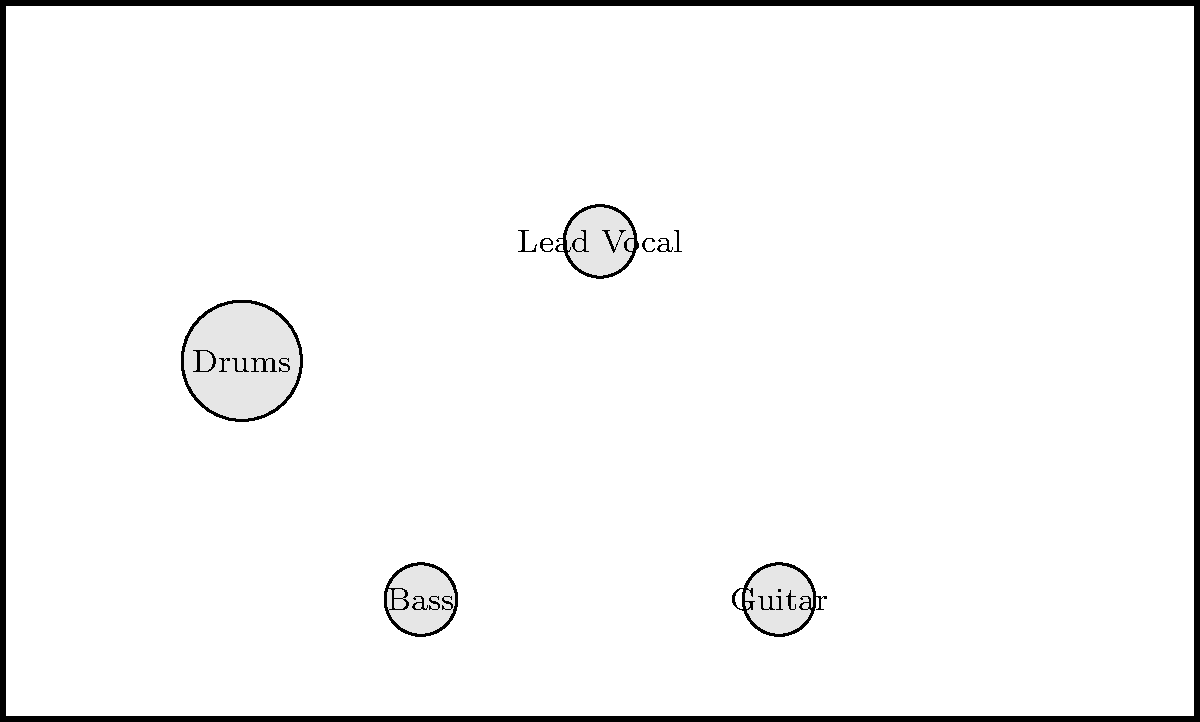As you prepare for your next live performance, you're given this stage plot diagram. Which instrument or position is placed furthest downstage (closest to the audience) according to the diagram? To answer this question, we need to analyze the stage plot diagram and understand the concept of stage positioning:

1. In stage terminology, "downstage" refers to the area of the stage closest to the audience, while "upstage" is furthest from the audience.

2. In this diagram, the bottom of the image represents the front of the stage (downstage), and the top represents the back of the stage (upstage).

3. Let's examine the positions of each instrument/performer:
   - Drums: Located near the center, slightly towards the back
   - Lead Vocal: Positioned in the center, slightly forward
   - Bass: Placed on the left side, close to the front
   - Guitar: Placed on the right side, close to the front
   - Keyboard: Located on the far right, towards the back

4. Comparing the vertical positions of these elements, we can see that the Bass and Guitar are placed closest to the bottom of the diagram.

5. Both the Bass and Guitar are at the same vertical position, but we need to choose one for the answer.

6. Since the question asks for an instrument or position, we can choose either the Bass or Guitar as they are both equally downstage.

Therefore, either the Bass or Guitar is placed furthest downstage (closest to the audience) according to the diagram.
Answer: Bass or Guitar 